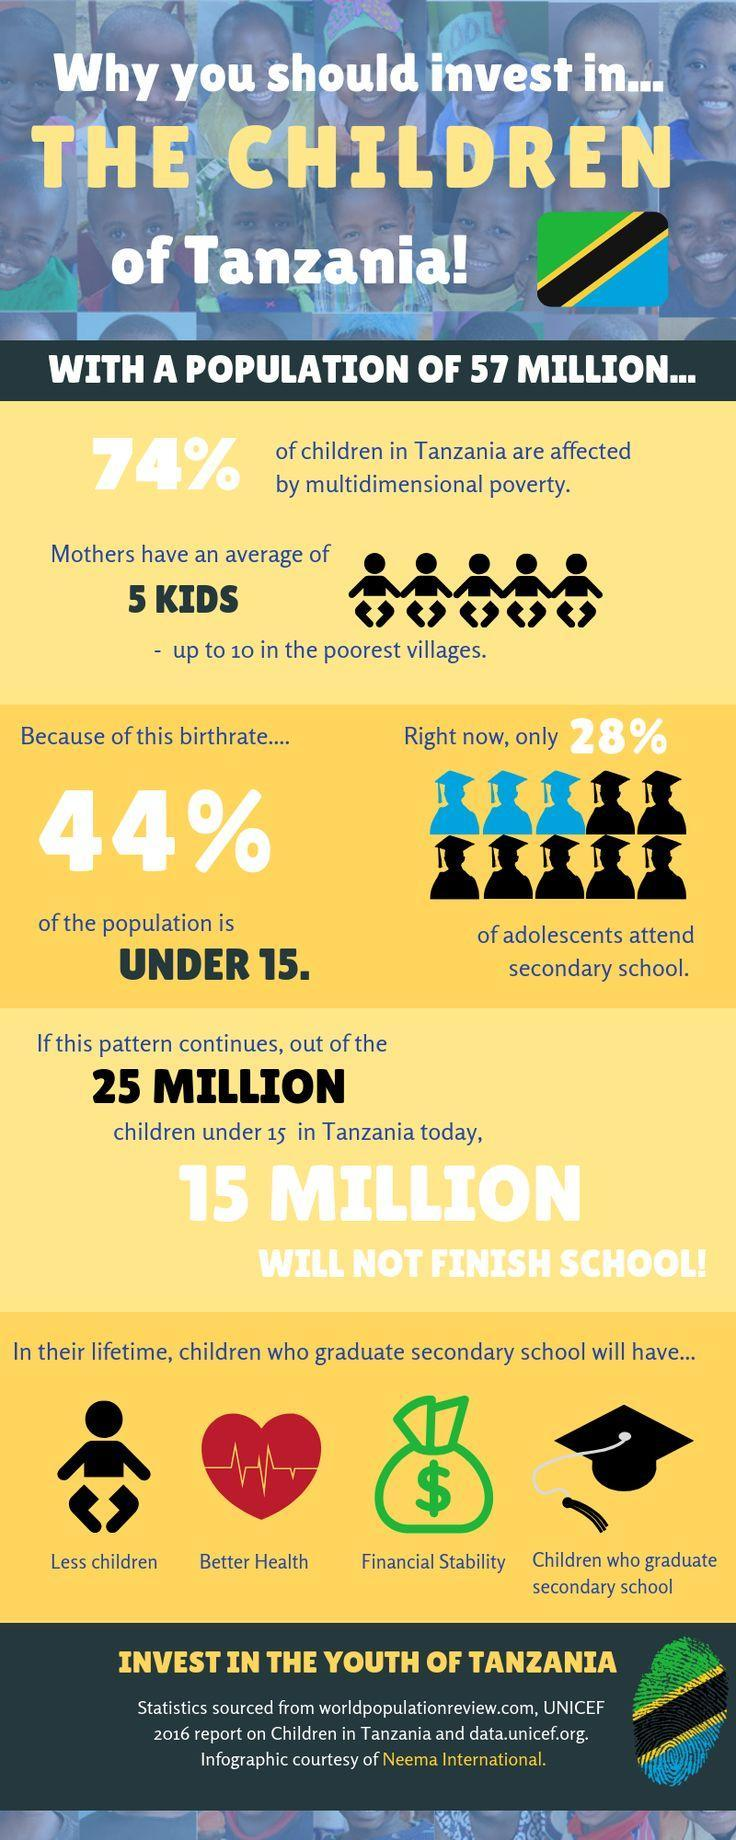What percent of population in Tanzania are aged under 15?
Answer the question with a short phrase. 44% What percent of children in Tanzania are not affected by multidimensional poverty? 26% 